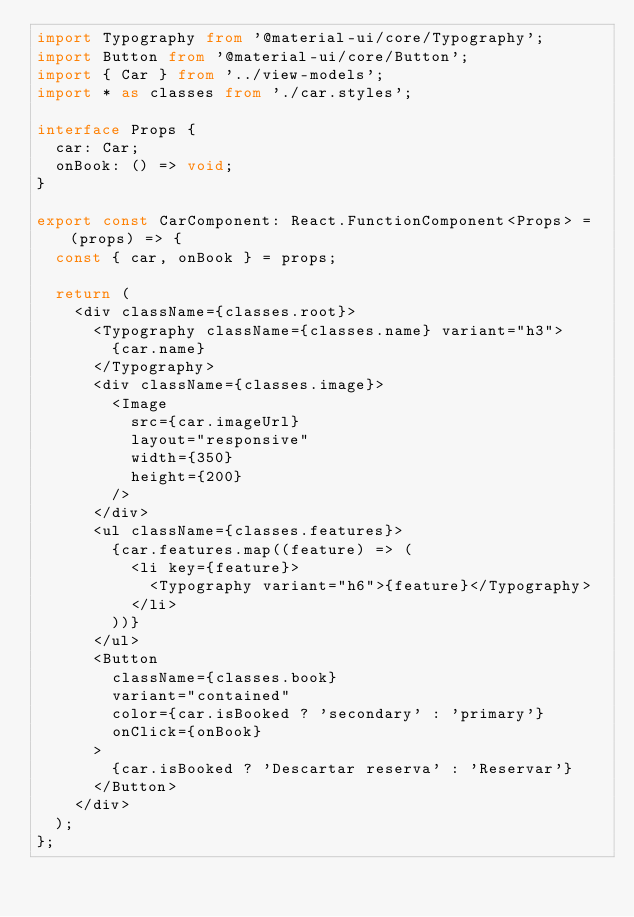<code> <loc_0><loc_0><loc_500><loc_500><_TypeScript_>import Typography from '@material-ui/core/Typography';
import Button from '@material-ui/core/Button';
import { Car } from '../view-models';
import * as classes from './car.styles';

interface Props {
  car: Car;
  onBook: () => void;
}

export const CarComponent: React.FunctionComponent<Props> = (props) => {
  const { car, onBook } = props;

  return (
    <div className={classes.root}>
      <Typography className={classes.name} variant="h3">
        {car.name}
      </Typography>
      <div className={classes.image}>
        <Image
          src={car.imageUrl}
          layout="responsive"
          width={350}
          height={200}
        />
      </div>
      <ul className={classes.features}>
        {car.features.map((feature) => (
          <li key={feature}>
            <Typography variant="h6">{feature}</Typography>
          </li>
        ))}
      </ul>
      <Button
        className={classes.book}
        variant="contained"
        color={car.isBooked ? 'secondary' : 'primary'}
        onClick={onBook}
      >
        {car.isBooked ? 'Descartar reserva' : 'Reservar'}
      </Button>
    </div>
  );
};
</code> 